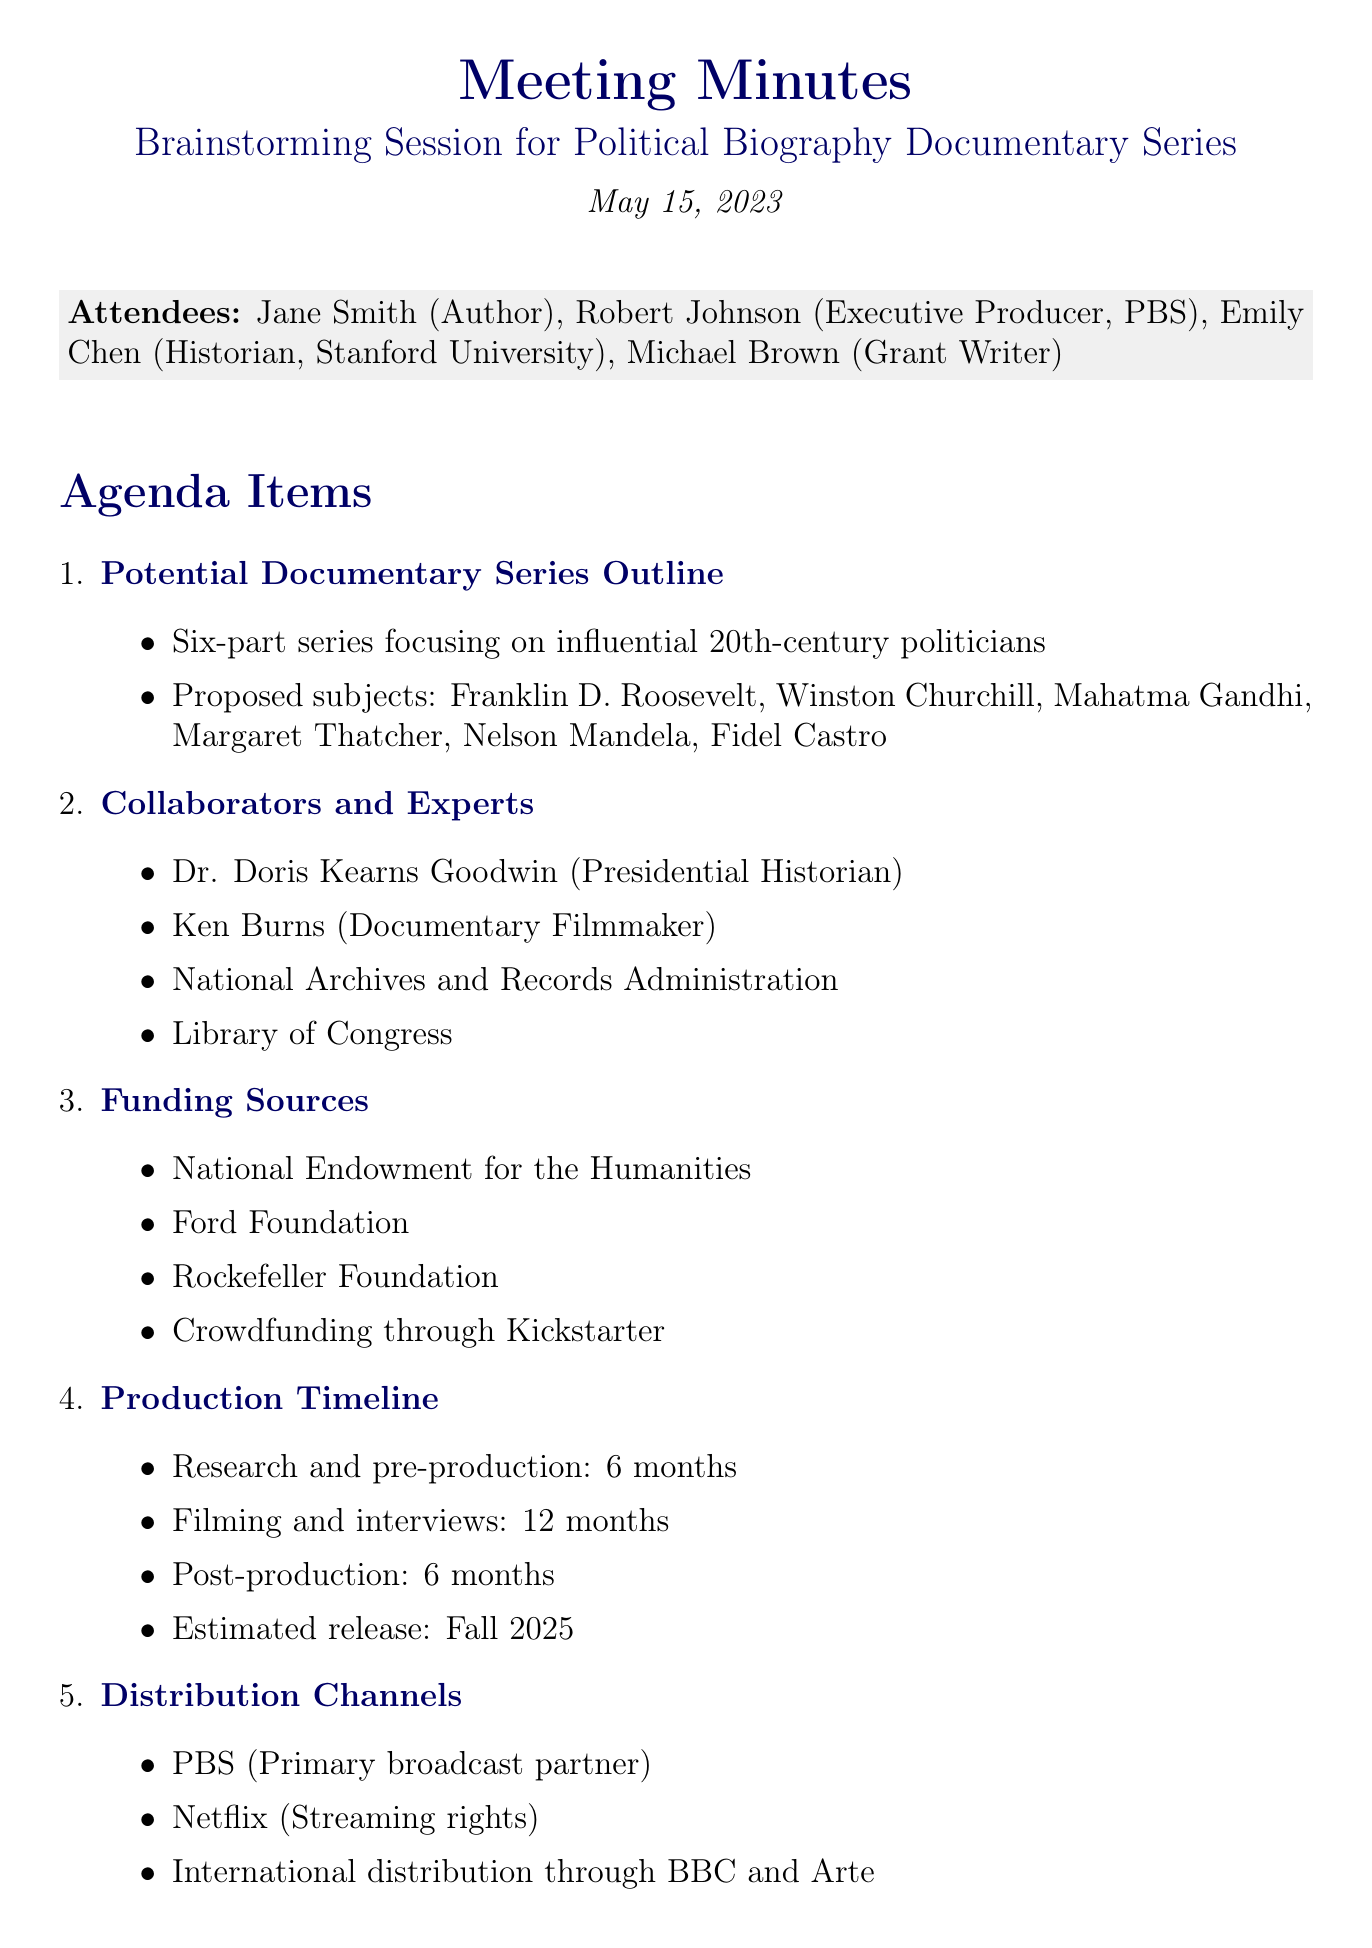What is the meeting title? The meeting title is explicitly mentioned at the top of the document.
Answer: Brainstorming Session for Political Biography Documentary Series Who is the author in attendance? The name of the author is listed in the attendees section.
Answer: Jane Smith What is the proposed length of the documentary series? The length of the series is specified in the outline of the agenda items.
Answer: Six parts What is one of the proposed subjects for the documentary series? The document lists specific subjects under the series outline.
Answer: Franklin D. Roosevelt Which foundation is mentioned as a funding source? Specific funding sources are detailed in the agenda items related to funding.
Answer: Ford Foundation Who is responsible for compiling a list of key archival sources? The action items section specifies who will handle tasks.
Answer: Emily What is the estimated release timeframe for the documentary? The estimated release date is listed under production timeline.
Answer: Fall 2025 Which streaming platform is mentioned for distribution rights? The document details distribution channels, including streaming partners.
Answer: Netflix What is the primary broadcast partner mentioned? The primary partner is outlined in the distribution channels section.
Answer: PBS 